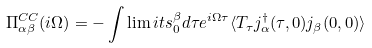Convert formula to latex. <formula><loc_0><loc_0><loc_500><loc_500>\Pi ^ { C C } _ { \alpha \beta } ( i \Omega ) = - \int \lim i t s _ { 0 } ^ { \beta } d \tau e ^ { i \Omega \tau } \langle T _ { \tau } j _ { \alpha } ^ { \dagger } ( \tau , 0 ) j _ { \beta } ( 0 , 0 ) \rangle</formula> 